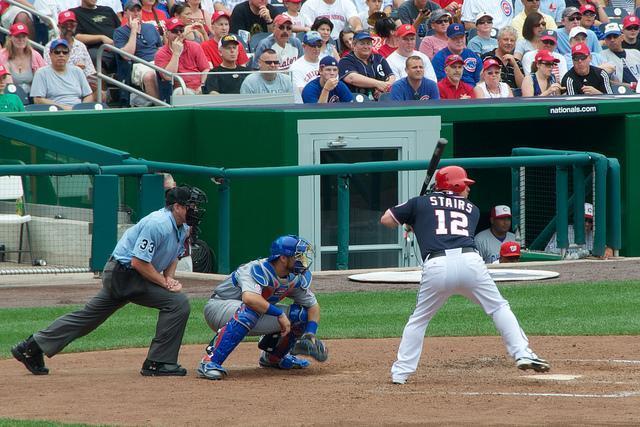How many people are there?
Give a very brief answer. 5. 